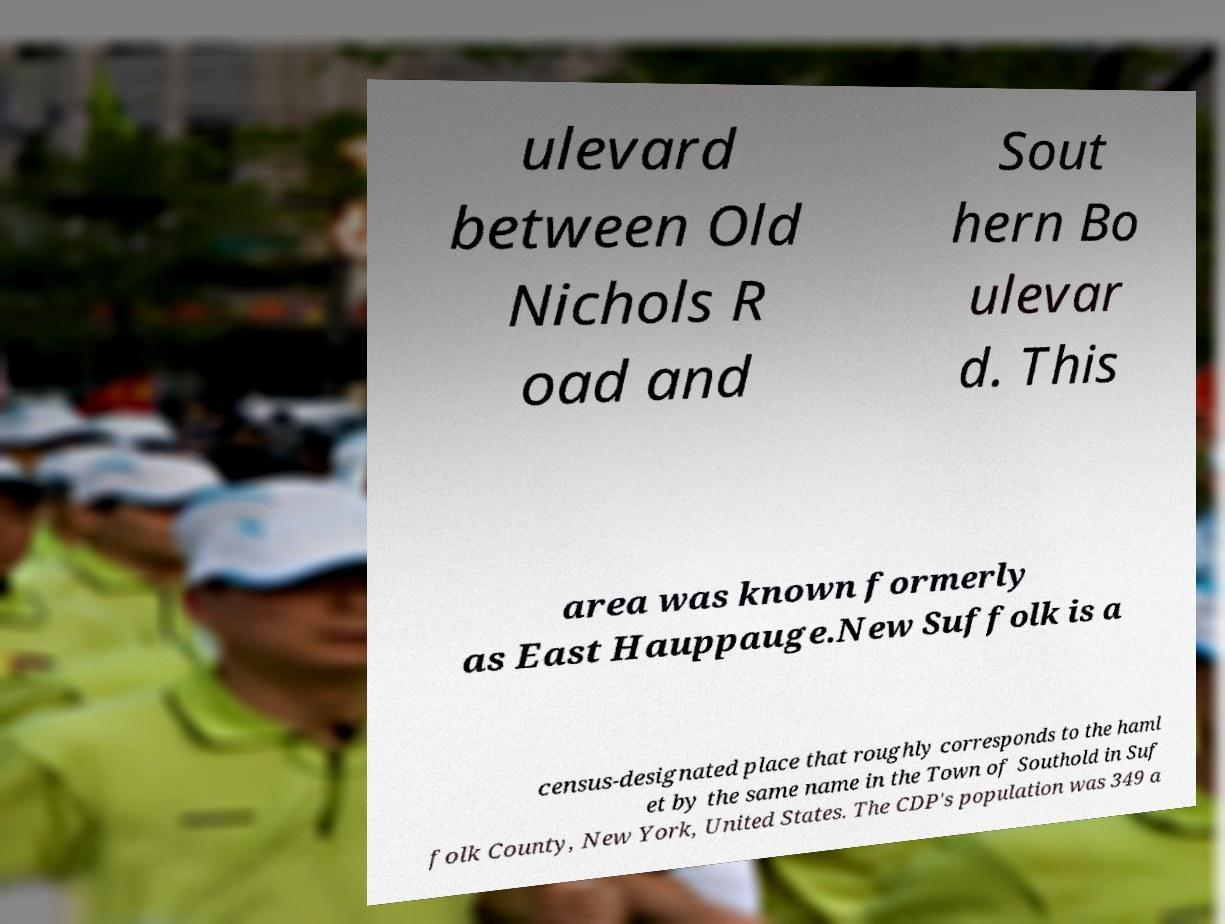Could you extract and type out the text from this image? ulevard between Old Nichols R oad and Sout hern Bo ulevar d. This area was known formerly as East Hauppauge.New Suffolk is a census-designated place that roughly corresponds to the haml et by the same name in the Town of Southold in Suf folk County, New York, United States. The CDP's population was 349 a 